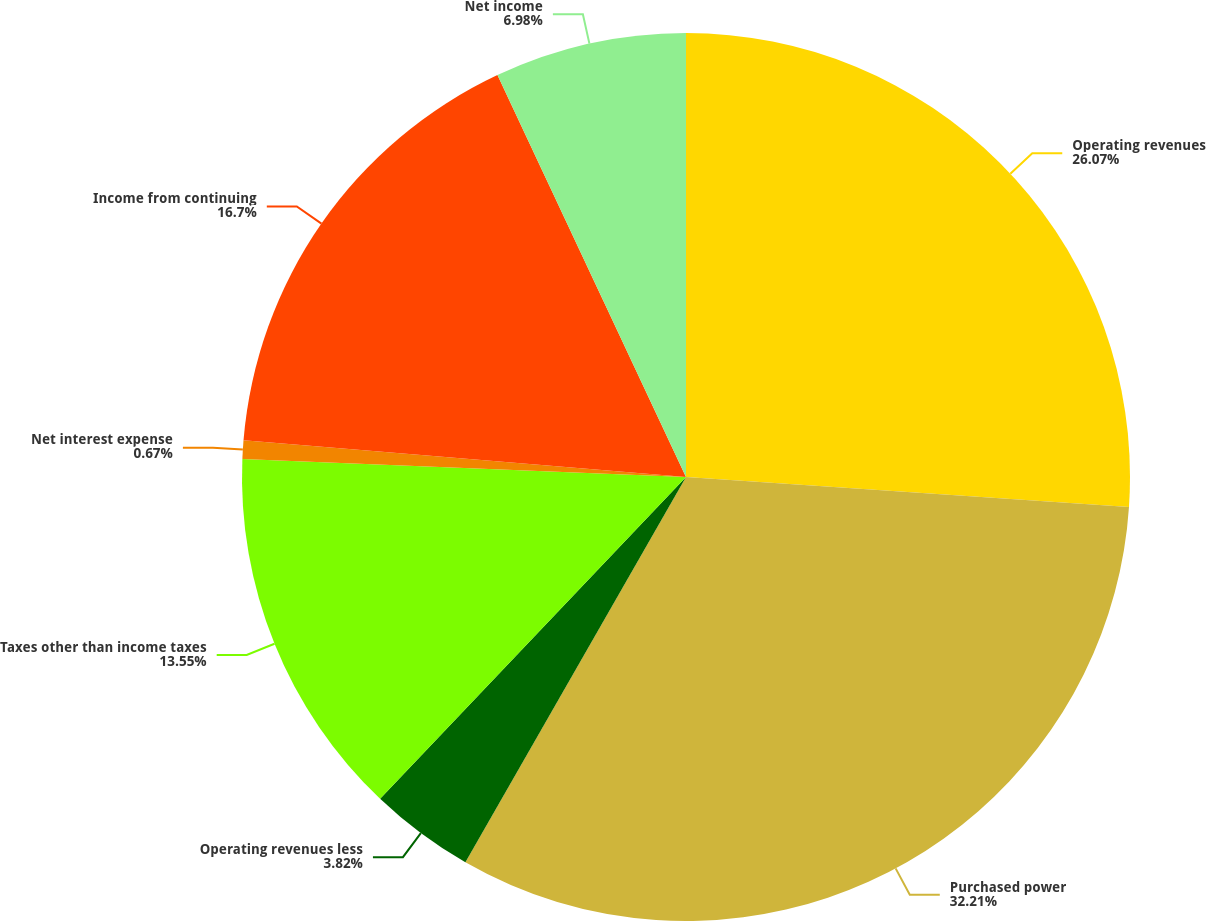Convert chart to OTSL. <chart><loc_0><loc_0><loc_500><loc_500><pie_chart><fcel>Operating revenues<fcel>Purchased power<fcel>Operating revenues less<fcel>Taxes other than income taxes<fcel>Net interest expense<fcel>Income from continuing<fcel>Net income<nl><fcel>26.07%<fcel>32.2%<fcel>3.82%<fcel>13.55%<fcel>0.67%<fcel>16.7%<fcel>6.98%<nl></chart> 